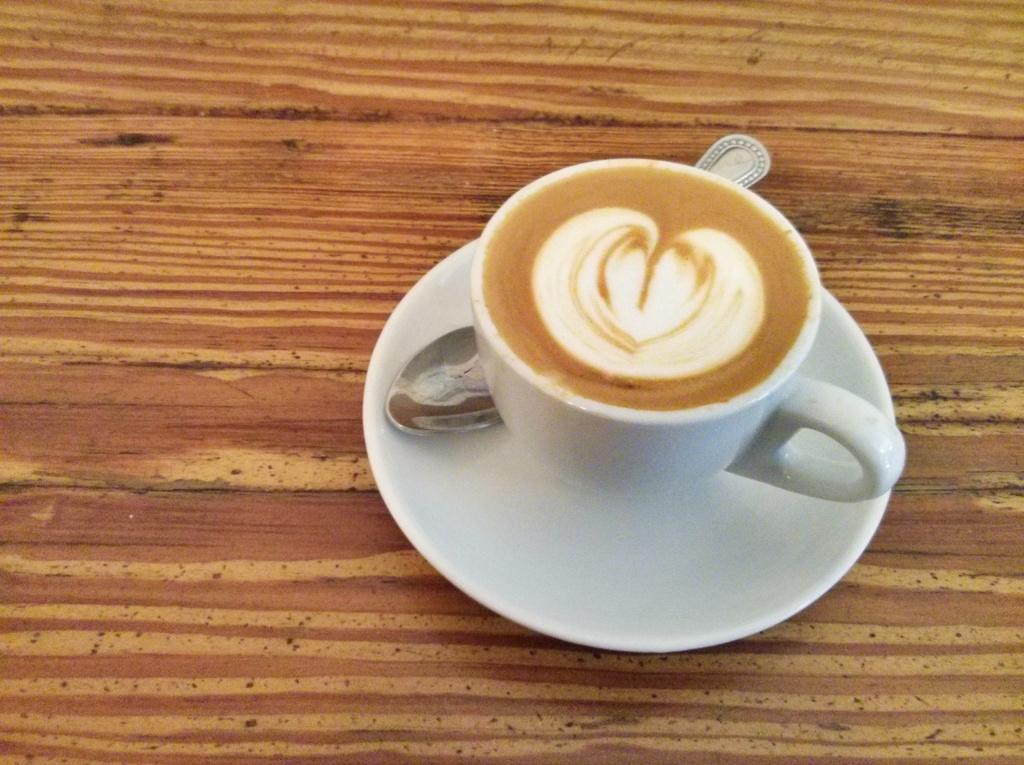What is in the cup that is visible in the image? There is a cup of tea in the image. What is the cup resting on in the image? There is a saucer in the image. What utensil is present in the image? There is a spoon in the image. What type of knowledge is being shared in the image? There is no indication of knowledge being shared in the image; it simply shows a cup of tea, a saucer, and a spoon. 